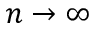<formula> <loc_0><loc_0><loc_500><loc_500>n \rightarrow \infty</formula> 